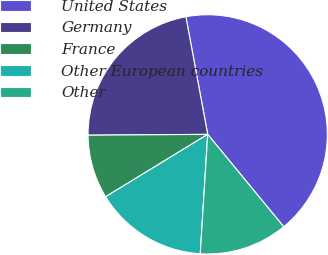Convert chart to OTSL. <chart><loc_0><loc_0><loc_500><loc_500><pie_chart><fcel>United States<fcel>Germany<fcel>France<fcel>Other European countries<fcel>Other<nl><fcel>41.96%<fcel>22.19%<fcel>8.62%<fcel>15.28%<fcel>11.95%<nl></chart> 